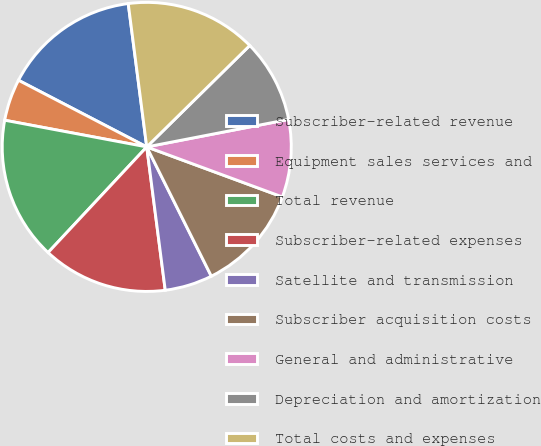<chart> <loc_0><loc_0><loc_500><loc_500><pie_chart><fcel>Subscriber-related revenue<fcel>Equipment sales services and<fcel>Total revenue<fcel>Subscriber-related expenses<fcel>Satellite and transmission<fcel>Subscriber acquisition costs<fcel>General and administrative<fcel>Depreciation and amortization<fcel>Total costs and expenses<nl><fcel>15.33%<fcel>4.67%<fcel>16.0%<fcel>14.0%<fcel>5.33%<fcel>12.0%<fcel>8.67%<fcel>9.33%<fcel>14.67%<nl></chart> 